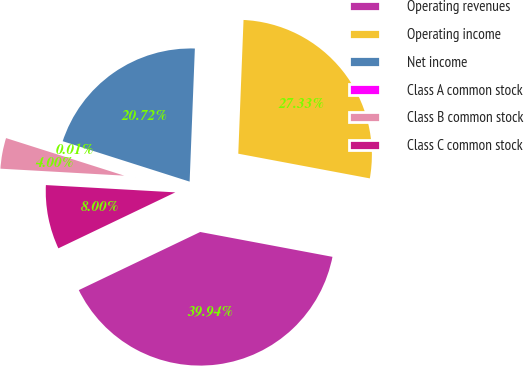<chart> <loc_0><loc_0><loc_500><loc_500><pie_chart><fcel>Operating revenues<fcel>Operating income<fcel>Net income<fcel>Class A common stock<fcel>Class B common stock<fcel>Class C common stock<nl><fcel>39.94%<fcel>27.33%<fcel>20.72%<fcel>0.01%<fcel>4.0%<fcel>8.0%<nl></chart> 